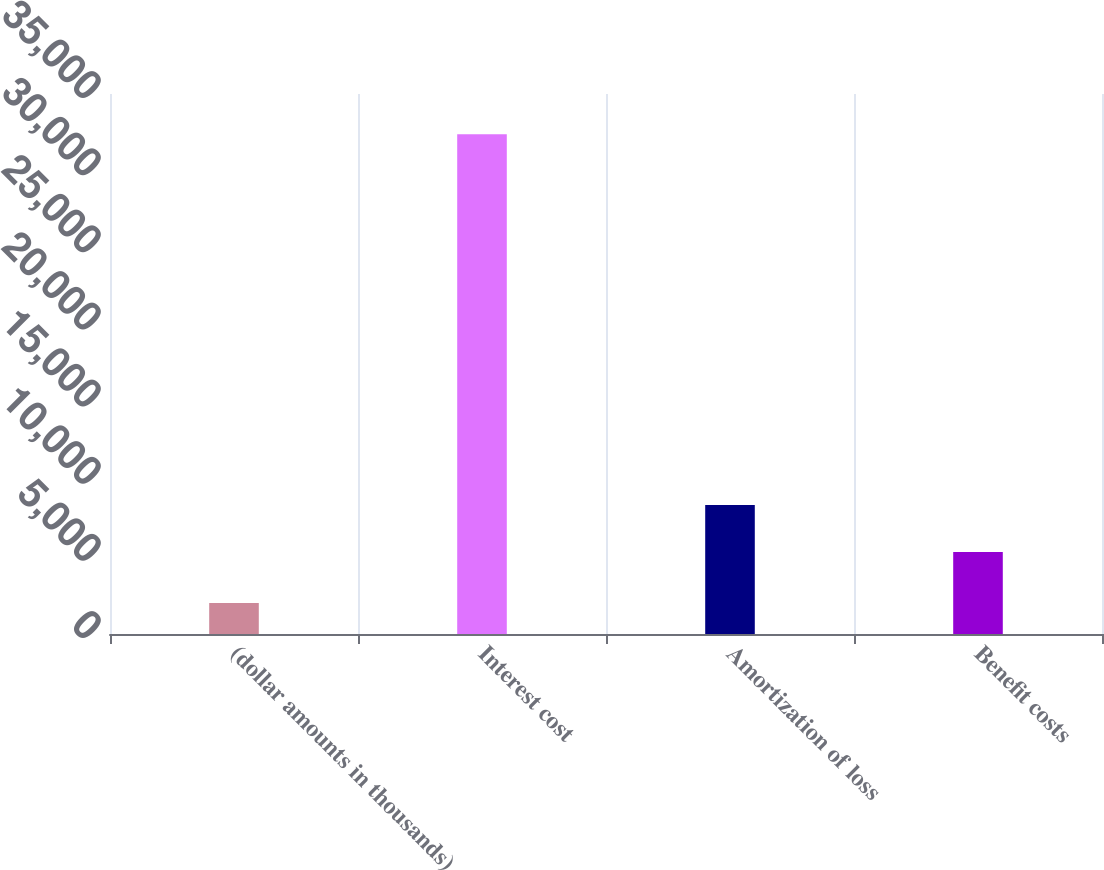<chart> <loc_0><loc_0><loc_500><loc_500><bar_chart><fcel>(dollar amounts in thousands)<fcel>Interest cost<fcel>Amortization of loss<fcel>Benefit costs<nl><fcel>2014<fcel>32398<fcel>8360.4<fcel>5322<nl></chart> 